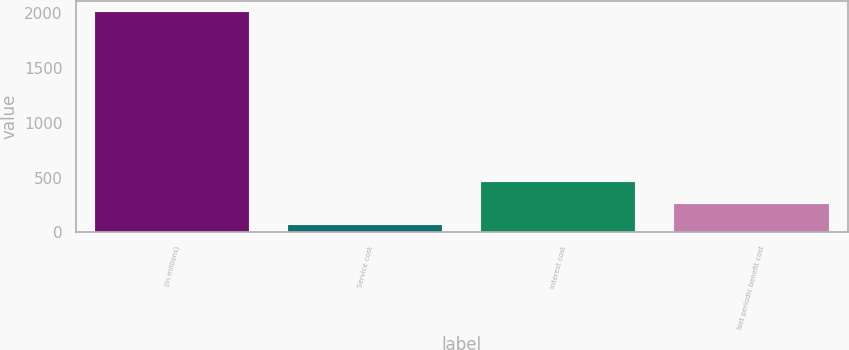Convert chart to OTSL. <chart><loc_0><loc_0><loc_500><loc_500><bar_chart><fcel>(in millions)<fcel>Service cost<fcel>Interest cost<fcel>Net periodic benefit cost<nl><fcel>2011<fcel>67<fcel>455.8<fcel>261.4<nl></chart> 